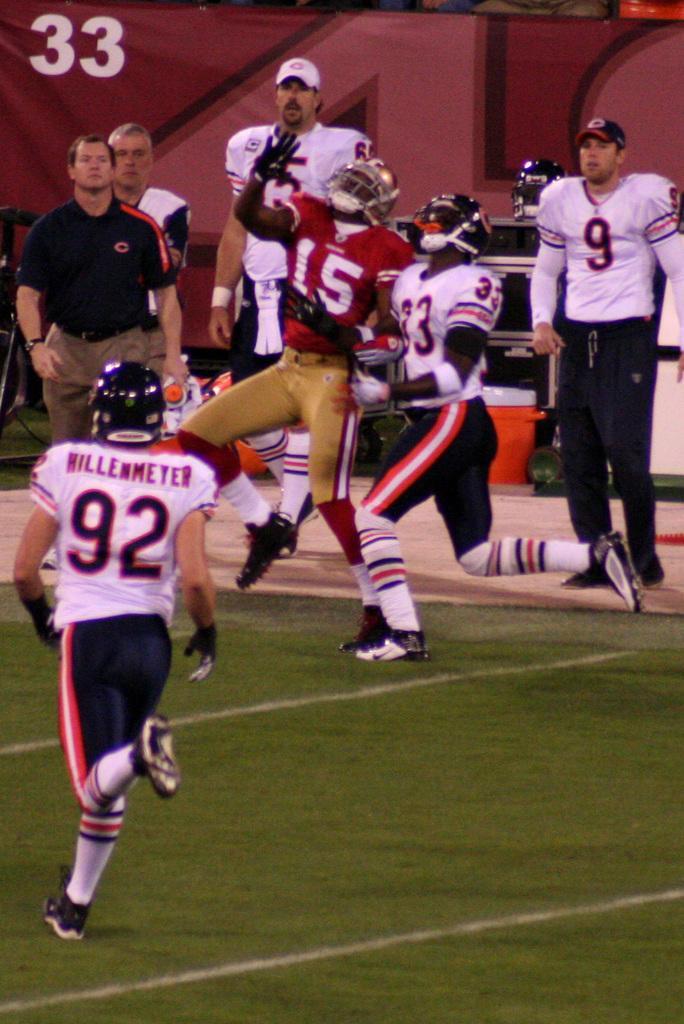In one or two sentences, can you explain what this image depicts? In this picture, we see seven men are standing. Three of them are playing the American football. At the bottom, we see the grass. Behind them, we see a table on which helmet is placed. We see an object in red and white color. On the left side, we see the railing. In the background, we see a sheet in maroon color with some text written on it. 